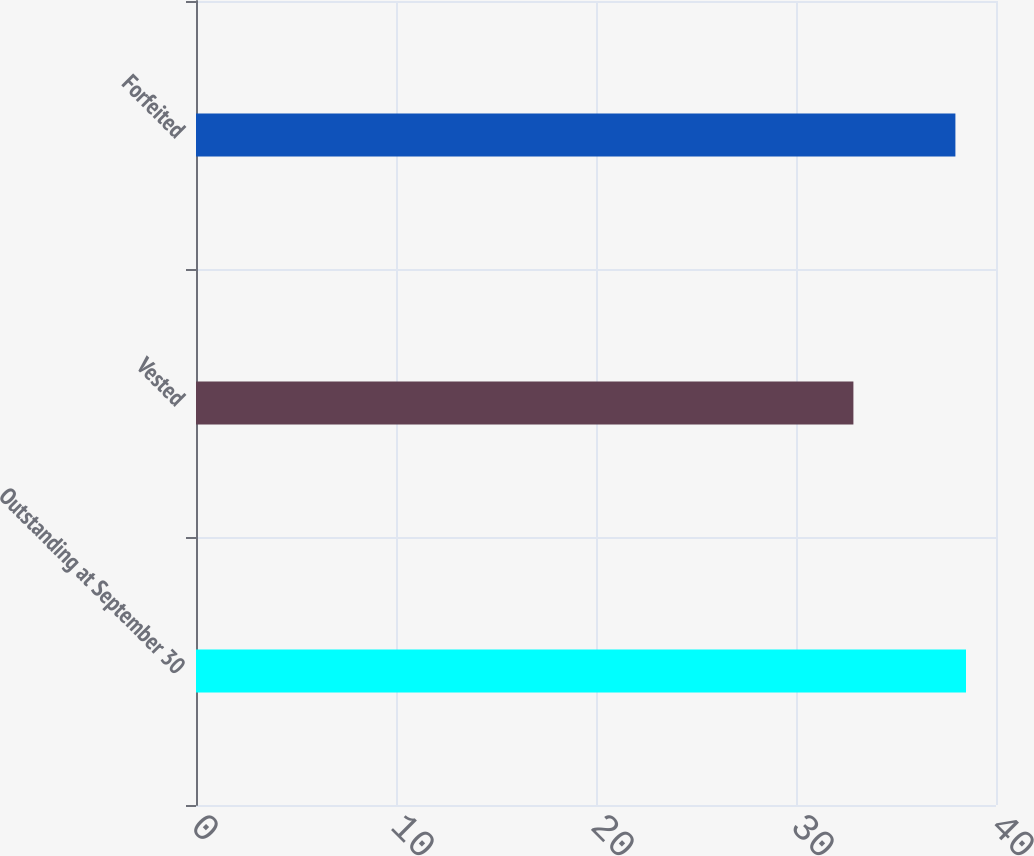Convert chart. <chart><loc_0><loc_0><loc_500><loc_500><bar_chart><fcel>Outstanding at September 30<fcel>Vested<fcel>Forfeited<nl><fcel>38.5<fcel>32.87<fcel>37.97<nl></chart> 